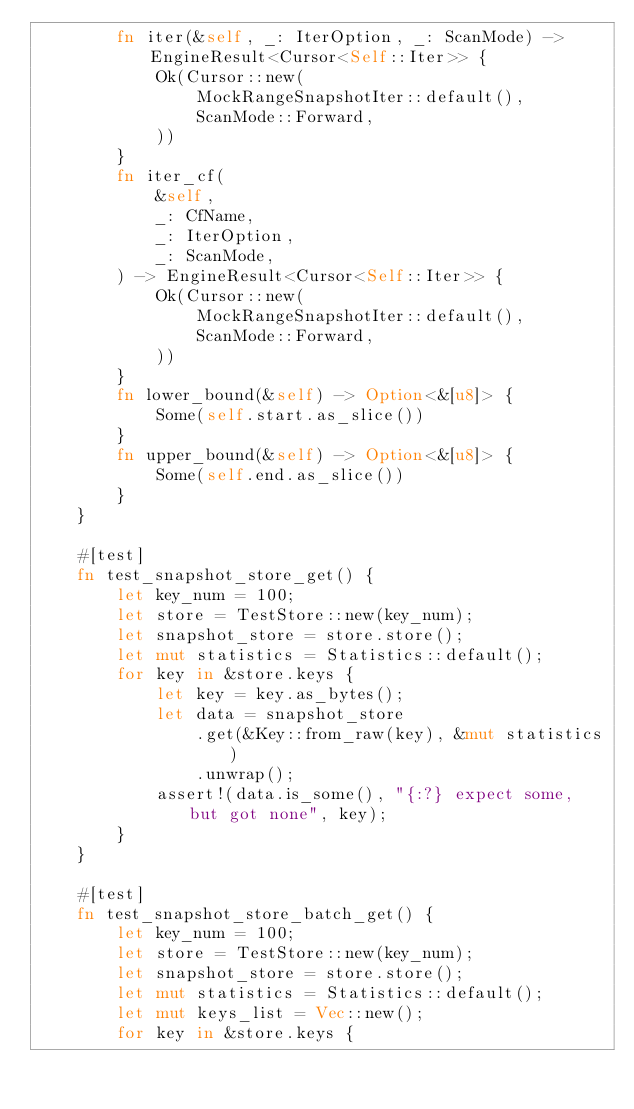Convert code to text. <code><loc_0><loc_0><loc_500><loc_500><_Rust_>        fn iter(&self, _: IterOption, _: ScanMode) -> EngineResult<Cursor<Self::Iter>> {
            Ok(Cursor::new(
                MockRangeSnapshotIter::default(),
                ScanMode::Forward,
            ))
        }
        fn iter_cf(
            &self,
            _: CfName,
            _: IterOption,
            _: ScanMode,
        ) -> EngineResult<Cursor<Self::Iter>> {
            Ok(Cursor::new(
                MockRangeSnapshotIter::default(),
                ScanMode::Forward,
            ))
        }
        fn lower_bound(&self) -> Option<&[u8]> {
            Some(self.start.as_slice())
        }
        fn upper_bound(&self) -> Option<&[u8]> {
            Some(self.end.as_slice())
        }
    }

    #[test]
    fn test_snapshot_store_get() {
        let key_num = 100;
        let store = TestStore::new(key_num);
        let snapshot_store = store.store();
        let mut statistics = Statistics::default();
        for key in &store.keys {
            let key = key.as_bytes();
            let data = snapshot_store
                .get(&Key::from_raw(key), &mut statistics)
                .unwrap();
            assert!(data.is_some(), "{:?} expect some, but got none", key);
        }
    }

    #[test]
    fn test_snapshot_store_batch_get() {
        let key_num = 100;
        let store = TestStore::new(key_num);
        let snapshot_store = store.store();
        let mut statistics = Statistics::default();
        let mut keys_list = Vec::new();
        for key in &store.keys {</code> 